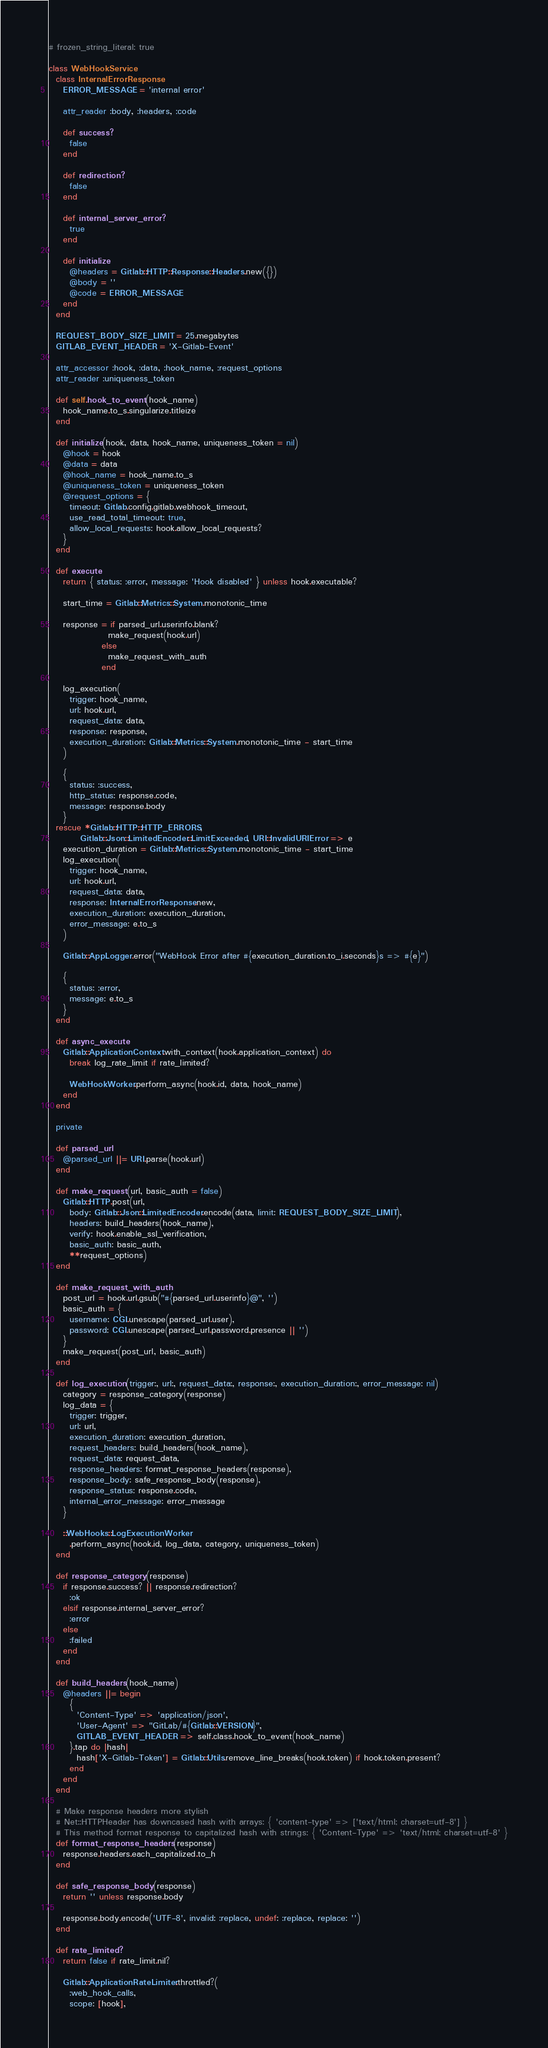<code> <loc_0><loc_0><loc_500><loc_500><_Ruby_># frozen_string_literal: true

class WebHookService
  class InternalErrorResponse
    ERROR_MESSAGE = 'internal error'

    attr_reader :body, :headers, :code

    def success?
      false
    end

    def redirection?
      false
    end

    def internal_server_error?
      true
    end

    def initialize
      @headers = Gitlab::HTTP::Response::Headers.new({})
      @body = ''
      @code = ERROR_MESSAGE
    end
  end

  REQUEST_BODY_SIZE_LIMIT = 25.megabytes
  GITLAB_EVENT_HEADER = 'X-Gitlab-Event'

  attr_accessor :hook, :data, :hook_name, :request_options
  attr_reader :uniqueness_token

  def self.hook_to_event(hook_name)
    hook_name.to_s.singularize.titleize
  end

  def initialize(hook, data, hook_name, uniqueness_token = nil)
    @hook = hook
    @data = data
    @hook_name = hook_name.to_s
    @uniqueness_token = uniqueness_token
    @request_options = {
      timeout: Gitlab.config.gitlab.webhook_timeout,
      use_read_total_timeout: true,
      allow_local_requests: hook.allow_local_requests?
    }
  end

  def execute
    return { status: :error, message: 'Hook disabled' } unless hook.executable?

    start_time = Gitlab::Metrics::System.monotonic_time

    response = if parsed_url.userinfo.blank?
                 make_request(hook.url)
               else
                 make_request_with_auth
               end

    log_execution(
      trigger: hook_name,
      url: hook.url,
      request_data: data,
      response: response,
      execution_duration: Gitlab::Metrics::System.monotonic_time - start_time
    )

    {
      status: :success,
      http_status: response.code,
      message: response.body
    }
  rescue *Gitlab::HTTP::HTTP_ERRORS,
         Gitlab::Json::LimitedEncoder::LimitExceeded, URI::InvalidURIError => e
    execution_duration = Gitlab::Metrics::System.monotonic_time - start_time
    log_execution(
      trigger: hook_name,
      url: hook.url,
      request_data: data,
      response: InternalErrorResponse.new,
      execution_duration: execution_duration,
      error_message: e.to_s
    )

    Gitlab::AppLogger.error("WebHook Error after #{execution_duration.to_i.seconds}s => #{e}")

    {
      status: :error,
      message: e.to_s
    }
  end

  def async_execute
    Gitlab::ApplicationContext.with_context(hook.application_context) do
      break log_rate_limit if rate_limited?

      WebHookWorker.perform_async(hook.id, data, hook_name)
    end
  end

  private

  def parsed_url
    @parsed_url ||= URI.parse(hook.url)
  end

  def make_request(url, basic_auth = false)
    Gitlab::HTTP.post(url,
      body: Gitlab::Json::LimitedEncoder.encode(data, limit: REQUEST_BODY_SIZE_LIMIT),
      headers: build_headers(hook_name),
      verify: hook.enable_ssl_verification,
      basic_auth: basic_auth,
      **request_options)
  end

  def make_request_with_auth
    post_url = hook.url.gsub("#{parsed_url.userinfo}@", '')
    basic_auth = {
      username: CGI.unescape(parsed_url.user),
      password: CGI.unescape(parsed_url.password.presence || '')
    }
    make_request(post_url, basic_auth)
  end

  def log_execution(trigger:, url:, request_data:, response:, execution_duration:, error_message: nil)
    category = response_category(response)
    log_data = {
      trigger: trigger,
      url: url,
      execution_duration: execution_duration,
      request_headers: build_headers(hook_name),
      request_data: request_data,
      response_headers: format_response_headers(response),
      response_body: safe_response_body(response),
      response_status: response.code,
      internal_error_message: error_message
    }

    ::WebHooks::LogExecutionWorker
      .perform_async(hook.id, log_data, category, uniqueness_token)
  end

  def response_category(response)
    if response.success? || response.redirection?
      :ok
    elsif response.internal_server_error?
      :error
    else
      :failed
    end
  end

  def build_headers(hook_name)
    @headers ||= begin
      {
        'Content-Type' => 'application/json',
        'User-Agent' => "GitLab/#{Gitlab::VERSION}",
        GITLAB_EVENT_HEADER => self.class.hook_to_event(hook_name)
      }.tap do |hash|
        hash['X-Gitlab-Token'] = Gitlab::Utils.remove_line_breaks(hook.token) if hook.token.present?
      end
    end
  end

  # Make response headers more stylish
  # Net::HTTPHeader has downcased hash with arrays: { 'content-type' => ['text/html; charset=utf-8'] }
  # This method format response to capitalized hash with strings: { 'Content-Type' => 'text/html; charset=utf-8' }
  def format_response_headers(response)
    response.headers.each_capitalized.to_h
  end

  def safe_response_body(response)
    return '' unless response.body

    response.body.encode('UTF-8', invalid: :replace, undef: :replace, replace: '')
  end

  def rate_limited?
    return false if rate_limit.nil?

    Gitlab::ApplicationRateLimiter.throttled?(
      :web_hook_calls,
      scope: [hook],</code> 